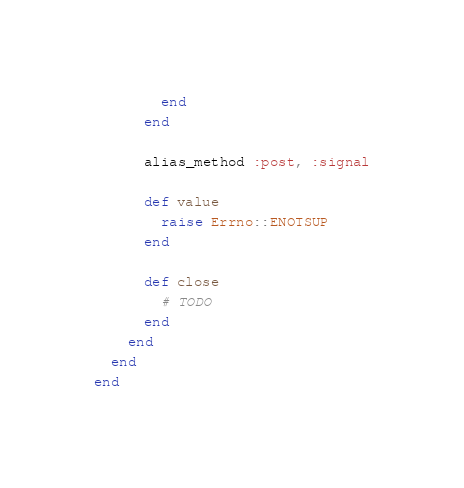<code> <loc_0><loc_0><loc_500><loc_500><_Ruby_>        end
      end

      alias_method :post, :signal

      def value
        raise Errno::ENOTSUP
      end

      def close
        # TODO
      end
    end
  end
end
</code> 